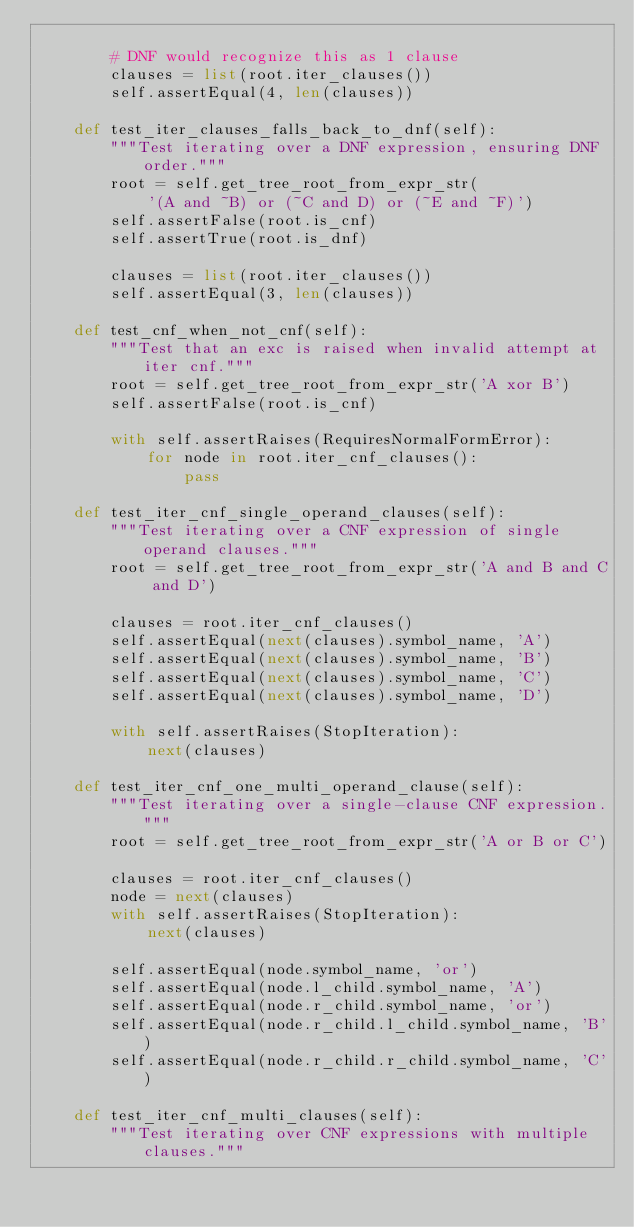<code> <loc_0><loc_0><loc_500><loc_500><_Python_>
        # DNF would recognize this as 1 clause
        clauses = list(root.iter_clauses())
        self.assertEqual(4, len(clauses))

    def test_iter_clauses_falls_back_to_dnf(self):
        """Test iterating over a DNF expression, ensuring DNF order."""
        root = self.get_tree_root_from_expr_str(
            '(A and ~B) or (~C and D) or (~E and ~F)')
        self.assertFalse(root.is_cnf)
        self.assertTrue(root.is_dnf)

        clauses = list(root.iter_clauses())
        self.assertEqual(3, len(clauses))

    def test_cnf_when_not_cnf(self):
        """Test that an exc is raised when invalid attempt at iter cnf."""
        root = self.get_tree_root_from_expr_str('A xor B')
        self.assertFalse(root.is_cnf)

        with self.assertRaises(RequiresNormalFormError):
            for node in root.iter_cnf_clauses():
                pass

    def test_iter_cnf_single_operand_clauses(self):
        """Test iterating over a CNF expression of single operand clauses."""
        root = self.get_tree_root_from_expr_str('A and B and C and D')

        clauses = root.iter_cnf_clauses()
        self.assertEqual(next(clauses).symbol_name, 'A')
        self.assertEqual(next(clauses).symbol_name, 'B')
        self.assertEqual(next(clauses).symbol_name, 'C')
        self.assertEqual(next(clauses).symbol_name, 'D')

        with self.assertRaises(StopIteration):
            next(clauses)

    def test_iter_cnf_one_multi_operand_clause(self):
        """Test iterating over a single-clause CNF expression."""
        root = self.get_tree_root_from_expr_str('A or B or C')

        clauses = root.iter_cnf_clauses()
        node = next(clauses)
        with self.assertRaises(StopIteration):
            next(clauses)

        self.assertEqual(node.symbol_name, 'or')
        self.assertEqual(node.l_child.symbol_name, 'A')
        self.assertEqual(node.r_child.symbol_name, 'or')
        self.assertEqual(node.r_child.l_child.symbol_name, 'B')
        self.assertEqual(node.r_child.r_child.symbol_name, 'C')

    def test_iter_cnf_multi_clauses(self):
        """Test iterating over CNF expressions with multiple clauses."""</code> 